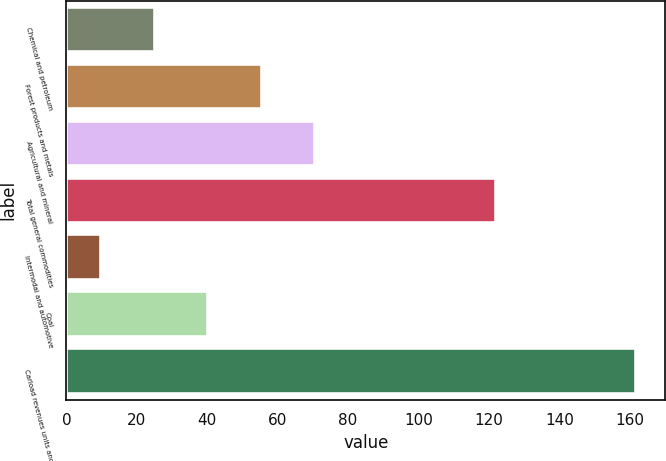Convert chart. <chart><loc_0><loc_0><loc_500><loc_500><bar_chart><fcel>Chemical and petroleum<fcel>Forest products and metals<fcel>Agricultural and mineral<fcel>Total general commodities<fcel>Intermodal and automotive<fcel>Coal<fcel>Carload revenues units and<nl><fcel>25.01<fcel>55.43<fcel>70.64<fcel>121.9<fcel>9.8<fcel>40.22<fcel>161.9<nl></chart> 